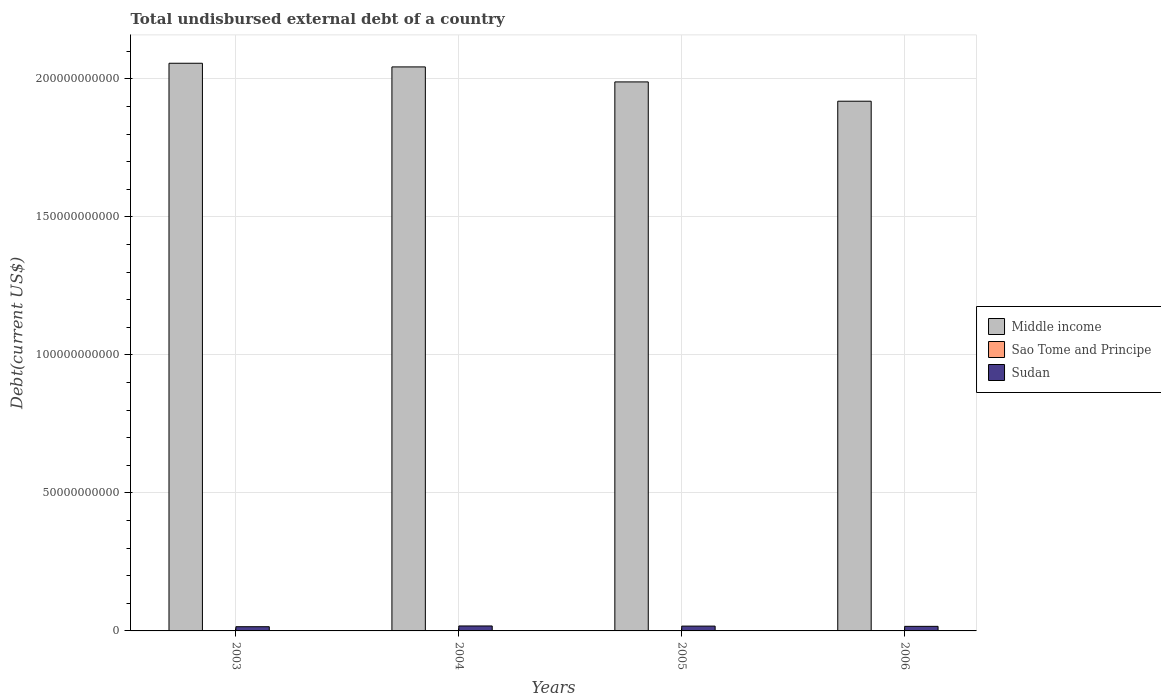How many different coloured bars are there?
Your answer should be very brief. 3. How many bars are there on the 3rd tick from the right?
Offer a very short reply. 3. In how many cases, is the number of bars for a given year not equal to the number of legend labels?
Your answer should be compact. 0. What is the total undisbursed external debt in Middle income in 2006?
Your answer should be compact. 1.92e+11. Across all years, what is the maximum total undisbursed external debt in Sudan?
Provide a succinct answer. 1.80e+09. Across all years, what is the minimum total undisbursed external debt in Sao Tome and Principe?
Your answer should be compact. 2.65e+07. What is the total total undisbursed external debt in Middle income in the graph?
Your response must be concise. 8.01e+11. What is the difference between the total undisbursed external debt in Sao Tome and Principe in 2003 and that in 2005?
Ensure brevity in your answer.  1.18e+07. What is the difference between the total undisbursed external debt in Sao Tome and Principe in 2005 and the total undisbursed external debt in Sudan in 2004?
Give a very brief answer. -1.77e+09. What is the average total undisbursed external debt in Middle income per year?
Keep it short and to the point. 2.00e+11. In the year 2005, what is the difference between the total undisbursed external debt in Middle income and total undisbursed external debt in Sao Tome and Principe?
Make the answer very short. 1.99e+11. In how many years, is the total undisbursed external debt in Middle income greater than 160000000000 US$?
Provide a short and direct response. 4. What is the ratio of the total undisbursed external debt in Sudan in 2003 to that in 2004?
Offer a terse response. 0.85. Is the total undisbursed external debt in Sudan in 2004 less than that in 2005?
Keep it short and to the point. No. Is the difference between the total undisbursed external debt in Middle income in 2003 and 2004 greater than the difference between the total undisbursed external debt in Sao Tome and Principe in 2003 and 2004?
Your answer should be very brief. Yes. What is the difference between the highest and the second highest total undisbursed external debt in Middle income?
Offer a terse response. 1.32e+09. What is the difference between the highest and the lowest total undisbursed external debt in Sudan?
Provide a short and direct response. 2.71e+08. What does the 2nd bar from the left in 2005 represents?
Provide a short and direct response. Sao Tome and Principe. What does the 2nd bar from the right in 2006 represents?
Give a very brief answer. Sao Tome and Principe. How many bars are there?
Ensure brevity in your answer.  12. How many years are there in the graph?
Your answer should be compact. 4. What is the difference between two consecutive major ticks on the Y-axis?
Keep it short and to the point. 5.00e+1. Are the values on the major ticks of Y-axis written in scientific E-notation?
Keep it short and to the point. No. How many legend labels are there?
Offer a terse response. 3. How are the legend labels stacked?
Make the answer very short. Vertical. What is the title of the graph?
Your response must be concise. Total undisbursed external debt of a country. What is the label or title of the X-axis?
Offer a terse response. Years. What is the label or title of the Y-axis?
Keep it short and to the point. Debt(current US$). What is the Debt(current US$) of Middle income in 2003?
Provide a short and direct response. 2.06e+11. What is the Debt(current US$) in Sao Tome and Principe in 2003?
Provide a succinct answer. 4.12e+07. What is the Debt(current US$) in Sudan in 2003?
Ensure brevity in your answer.  1.53e+09. What is the Debt(current US$) in Middle income in 2004?
Make the answer very short. 2.04e+11. What is the Debt(current US$) in Sao Tome and Principe in 2004?
Provide a short and direct response. 3.71e+07. What is the Debt(current US$) in Sudan in 2004?
Your response must be concise. 1.80e+09. What is the Debt(current US$) in Middle income in 2005?
Your answer should be compact. 1.99e+11. What is the Debt(current US$) of Sao Tome and Principe in 2005?
Keep it short and to the point. 2.94e+07. What is the Debt(current US$) in Sudan in 2005?
Make the answer very short. 1.75e+09. What is the Debt(current US$) in Middle income in 2006?
Your answer should be very brief. 1.92e+11. What is the Debt(current US$) of Sao Tome and Principe in 2006?
Your answer should be very brief. 2.65e+07. What is the Debt(current US$) of Sudan in 2006?
Provide a succinct answer. 1.65e+09. Across all years, what is the maximum Debt(current US$) of Middle income?
Keep it short and to the point. 2.06e+11. Across all years, what is the maximum Debt(current US$) of Sao Tome and Principe?
Provide a succinct answer. 4.12e+07. Across all years, what is the maximum Debt(current US$) of Sudan?
Your response must be concise. 1.80e+09. Across all years, what is the minimum Debt(current US$) in Middle income?
Provide a short and direct response. 1.92e+11. Across all years, what is the minimum Debt(current US$) of Sao Tome and Principe?
Provide a short and direct response. 2.65e+07. Across all years, what is the minimum Debt(current US$) in Sudan?
Keep it short and to the point. 1.53e+09. What is the total Debt(current US$) of Middle income in the graph?
Provide a short and direct response. 8.01e+11. What is the total Debt(current US$) of Sao Tome and Principe in the graph?
Keep it short and to the point. 1.34e+08. What is the total Debt(current US$) of Sudan in the graph?
Provide a succinct answer. 6.73e+09. What is the difference between the Debt(current US$) of Middle income in 2003 and that in 2004?
Give a very brief answer. 1.32e+09. What is the difference between the Debt(current US$) in Sao Tome and Principe in 2003 and that in 2004?
Your answer should be very brief. 4.09e+06. What is the difference between the Debt(current US$) in Sudan in 2003 and that in 2004?
Offer a terse response. -2.71e+08. What is the difference between the Debt(current US$) in Middle income in 2003 and that in 2005?
Provide a short and direct response. 6.76e+09. What is the difference between the Debt(current US$) in Sao Tome and Principe in 2003 and that in 2005?
Give a very brief answer. 1.18e+07. What is the difference between the Debt(current US$) of Sudan in 2003 and that in 2005?
Offer a very short reply. -2.20e+08. What is the difference between the Debt(current US$) of Middle income in 2003 and that in 2006?
Offer a terse response. 1.38e+1. What is the difference between the Debt(current US$) in Sao Tome and Principe in 2003 and that in 2006?
Provide a short and direct response. 1.46e+07. What is the difference between the Debt(current US$) of Sudan in 2003 and that in 2006?
Your answer should be very brief. -1.27e+08. What is the difference between the Debt(current US$) of Middle income in 2004 and that in 2005?
Provide a succinct answer. 5.43e+09. What is the difference between the Debt(current US$) of Sao Tome and Principe in 2004 and that in 2005?
Provide a succinct answer. 7.72e+06. What is the difference between the Debt(current US$) in Sudan in 2004 and that in 2005?
Provide a short and direct response. 5.05e+07. What is the difference between the Debt(current US$) of Middle income in 2004 and that in 2006?
Your answer should be compact. 1.24e+1. What is the difference between the Debt(current US$) in Sao Tome and Principe in 2004 and that in 2006?
Ensure brevity in your answer.  1.06e+07. What is the difference between the Debt(current US$) in Sudan in 2004 and that in 2006?
Provide a short and direct response. 1.44e+08. What is the difference between the Debt(current US$) in Middle income in 2005 and that in 2006?
Give a very brief answer. 6.99e+09. What is the difference between the Debt(current US$) in Sao Tome and Principe in 2005 and that in 2006?
Provide a short and direct response. 2.83e+06. What is the difference between the Debt(current US$) of Sudan in 2005 and that in 2006?
Provide a short and direct response. 9.31e+07. What is the difference between the Debt(current US$) of Middle income in 2003 and the Debt(current US$) of Sao Tome and Principe in 2004?
Provide a succinct answer. 2.06e+11. What is the difference between the Debt(current US$) of Middle income in 2003 and the Debt(current US$) of Sudan in 2004?
Ensure brevity in your answer.  2.04e+11. What is the difference between the Debt(current US$) of Sao Tome and Principe in 2003 and the Debt(current US$) of Sudan in 2004?
Offer a terse response. -1.76e+09. What is the difference between the Debt(current US$) in Middle income in 2003 and the Debt(current US$) in Sao Tome and Principe in 2005?
Offer a terse response. 2.06e+11. What is the difference between the Debt(current US$) of Middle income in 2003 and the Debt(current US$) of Sudan in 2005?
Your answer should be compact. 2.04e+11. What is the difference between the Debt(current US$) in Sao Tome and Principe in 2003 and the Debt(current US$) in Sudan in 2005?
Offer a very short reply. -1.71e+09. What is the difference between the Debt(current US$) of Middle income in 2003 and the Debt(current US$) of Sao Tome and Principe in 2006?
Keep it short and to the point. 2.06e+11. What is the difference between the Debt(current US$) in Middle income in 2003 and the Debt(current US$) in Sudan in 2006?
Give a very brief answer. 2.04e+11. What is the difference between the Debt(current US$) in Sao Tome and Principe in 2003 and the Debt(current US$) in Sudan in 2006?
Your response must be concise. -1.61e+09. What is the difference between the Debt(current US$) in Middle income in 2004 and the Debt(current US$) in Sao Tome and Principe in 2005?
Provide a short and direct response. 2.04e+11. What is the difference between the Debt(current US$) of Middle income in 2004 and the Debt(current US$) of Sudan in 2005?
Your answer should be compact. 2.03e+11. What is the difference between the Debt(current US$) of Sao Tome and Principe in 2004 and the Debt(current US$) of Sudan in 2005?
Your answer should be compact. -1.71e+09. What is the difference between the Debt(current US$) of Middle income in 2004 and the Debt(current US$) of Sao Tome and Principe in 2006?
Provide a short and direct response. 2.04e+11. What is the difference between the Debt(current US$) in Middle income in 2004 and the Debt(current US$) in Sudan in 2006?
Make the answer very short. 2.03e+11. What is the difference between the Debt(current US$) in Sao Tome and Principe in 2004 and the Debt(current US$) in Sudan in 2006?
Give a very brief answer. -1.62e+09. What is the difference between the Debt(current US$) in Middle income in 2005 and the Debt(current US$) in Sao Tome and Principe in 2006?
Your answer should be very brief. 1.99e+11. What is the difference between the Debt(current US$) in Middle income in 2005 and the Debt(current US$) in Sudan in 2006?
Provide a succinct answer. 1.97e+11. What is the difference between the Debt(current US$) in Sao Tome and Principe in 2005 and the Debt(current US$) in Sudan in 2006?
Provide a succinct answer. -1.62e+09. What is the average Debt(current US$) of Middle income per year?
Keep it short and to the point. 2.00e+11. What is the average Debt(current US$) of Sao Tome and Principe per year?
Keep it short and to the point. 3.35e+07. What is the average Debt(current US$) in Sudan per year?
Provide a short and direct response. 1.68e+09. In the year 2003, what is the difference between the Debt(current US$) of Middle income and Debt(current US$) of Sao Tome and Principe?
Offer a terse response. 2.06e+11. In the year 2003, what is the difference between the Debt(current US$) in Middle income and Debt(current US$) in Sudan?
Give a very brief answer. 2.04e+11. In the year 2003, what is the difference between the Debt(current US$) in Sao Tome and Principe and Debt(current US$) in Sudan?
Provide a succinct answer. -1.49e+09. In the year 2004, what is the difference between the Debt(current US$) in Middle income and Debt(current US$) in Sao Tome and Principe?
Ensure brevity in your answer.  2.04e+11. In the year 2004, what is the difference between the Debt(current US$) of Middle income and Debt(current US$) of Sudan?
Provide a succinct answer. 2.03e+11. In the year 2004, what is the difference between the Debt(current US$) of Sao Tome and Principe and Debt(current US$) of Sudan?
Offer a terse response. -1.76e+09. In the year 2005, what is the difference between the Debt(current US$) of Middle income and Debt(current US$) of Sao Tome and Principe?
Keep it short and to the point. 1.99e+11. In the year 2005, what is the difference between the Debt(current US$) in Middle income and Debt(current US$) in Sudan?
Make the answer very short. 1.97e+11. In the year 2005, what is the difference between the Debt(current US$) of Sao Tome and Principe and Debt(current US$) of Sudan?
Keep it short and to the point. -1.72e+09. In the year 2006, what is the difference between the Debt(current US$) of Middle income and Debt(current US$) of Sao Tome and Principe?
Ensure brevity in your answer.  1.92e+11. In the year 2006, what is the difference between the Debt(current US$) in Middle income and Debt(current US$) in Sudan?
Provide a short and direct response. 1.90e+11. In the year 2006, what is the difference between the Debt(current US$) in Sao Tome and Principe and Debt(current US$) in Sudan?
Offer a very short reply. -1.63e+09. What is the ratio of the Debt(current US$) of Sao Tome and Principe in 2003 to that in 2004?
Make the answer very short. 1.11. What is the ratio of the Debt(current US$) in Sudan in 2003 to that in 2004?
Offer a very short reply. 0.85. What is the ratio of the Debt(current US$) in Middle income in 2003 to that in 2005?
Ensure brevity in your answer.  1.03. What is the ratio of the Debt(current US$) in Sao Tome and Principe in 2003 to that in 2005?
Provide a succinct answer. 1.4. What is the ratio of the Debt(current US$) of Sudan in 2003 to that in 2005?
Provide a short and direct response. 0.87. What is the ratio of the Debt(current US$) in Middle income in 2003 to that in 2006?
Offer a terse response. 1.07. What is the ratio of the Debt(current US$) in Sao Tome and Principe in 2003 to that in 2006?
Offer a terse response. 1.55. What is the ratio of the Debt(current US$) of Sudan in 2003 to that in 2006?
Keep it short and to the point. 0.92. What is the ratio of the Debt(current US$) in Middle income in 2004 to that in 2005?
Your answer should be compact. 1.03. What is the ratio of the Debt(current US$) in Sao Tome and Principe in 2004 to that in 2005?
Offer a very short reply. 1.26. What is the ratio of the Debt(current US$) in Sudan in 2004 to that in 2005?
Provide a short and direct response. 1.03. What is the ratio of the Debt(current US$) in Middle income in 2004 to that in 2006?
Keep it short and to the point. 1.06. What is the ratio of the Debt(current US$) in Sao Tome and Principe in 2004 to that in 2006?
Offer a terse response. 1.4. What is the ratio of the Debt(current US$) of Sudan in 2004 to that in 2006?
Your answer should be very brief. 1.09. What is the ratio of the Debt(current US$) of Middle income in 2005 to that in 2006?
Your answer should be compact. 1.04. What is the ratio of the Debt(current US$) of Sao Tome and Principe in 2005 to that in 2006?
Offer a terse response. 1.11. What is the ratio of the Debt(current US$) in Sudan in 2005 to that in 2006?
Offer a terse response. 1.06. What is the difference between the highest and the second highest Debt(current US$) of Middle income?
Offer a terse response. 1.32e+09. What is the difference between the highest and the second highest Debt(current US$) in Sao Tome and Principe?
Provide a succinct answer. 4.09e+06. What is the difference between the highest and the second highest Debt(current US$) in Sudan?
Your answer should be compact. 5.05e+07. What is the difference between the highest and the lowest Debt(current US$) of Middle income?
Offer a terse response. 1.38e+1. What is the difference between the highest and the lowest Debt(current US$) of Sao Tome and Principe?
Your response must be concise. 1.46e+07. What is the difference between the highest and the lowest Debt(current US$) of Sudan?
Make the answer very short. 2.71e+08. 